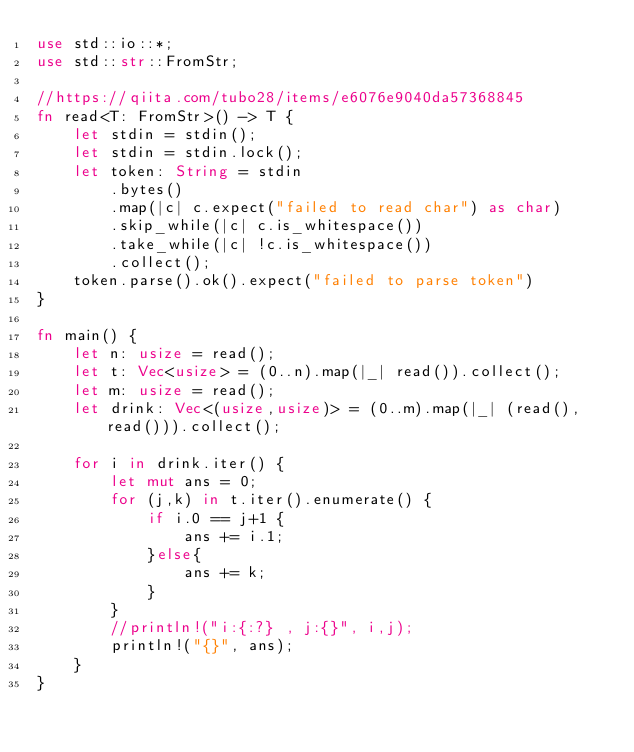Convert code to text. <code><loc_0><loc_0><loc_500><loc_500><_Rust_>use std::io::*;
use std::str::FromStr;

//https://qiita.com/tubo28/items/e6076e9040da57368845
fn read<T: FromStr>() -> T {
    let stdin = stdin();
    let stdin = stdin.lock();
    let token: String = stdin
        .bytes()
        .map(|c| c.expect("failed to read char") as char)
        .skip_while(|c| c.is_whitespace())
        .take_while(|c| !c.is_whitespace())
        .collect();
    token.parse().ok().expect("failed to parse token")
}

fn main() {
    let n: usize = read();
    let t: Vec<usize> = (0..n).map(|_| read()).collect();
    let m: usize = read();
    let drink: Vec<(usize,usize)> = (0..m).map(|_| (read(),read())).collect();

    for i in drink.iter() {
        let mut ans = 0;
        for (j,k) in t.iter().enumerate() {
            if i.0 == j+1 {
                ans += i.1;
            }else{
                ans += k;
            }
        }
        //println!("i:{:?} , j:{}", i,j);
        println!("{}", ans);
    }
}
</code> 